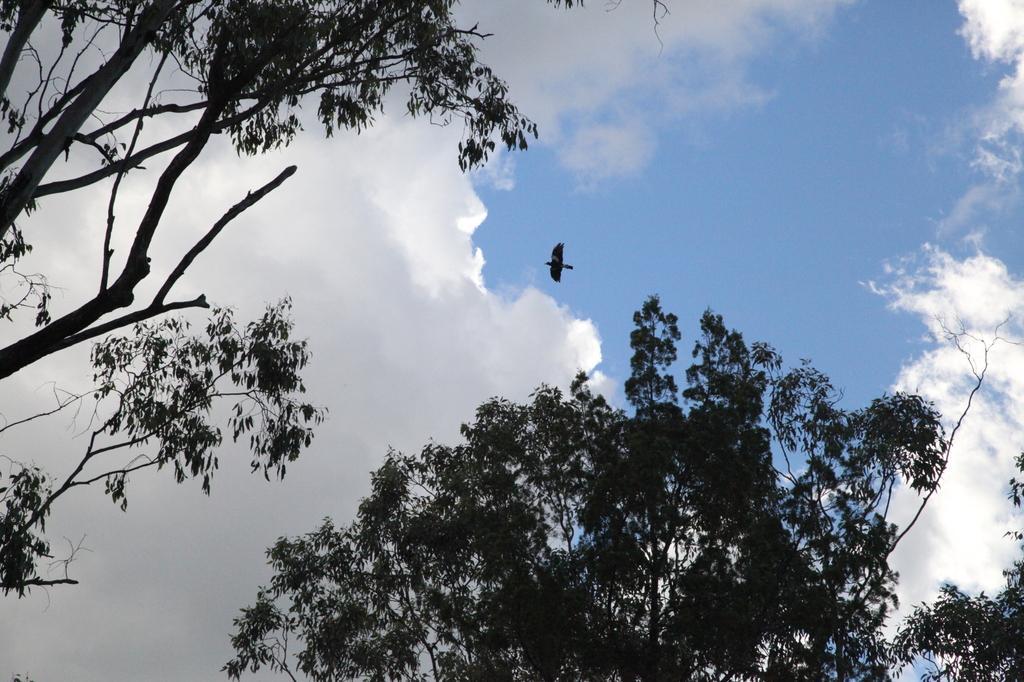How would you summarize this image in a sentence or two? In this image, we can see some trees. There is a bird in the middle of the image. There are clouds in the sky. 